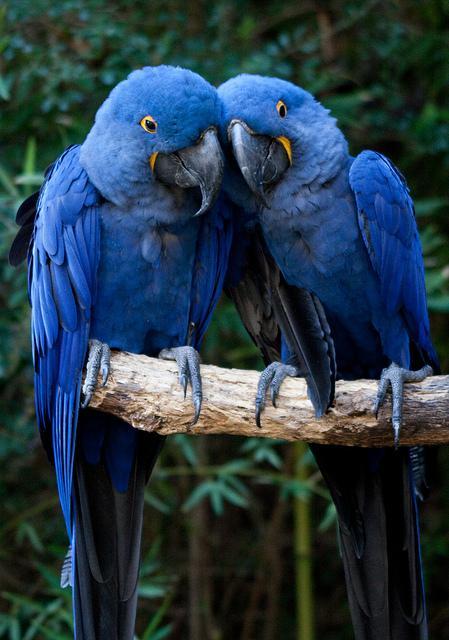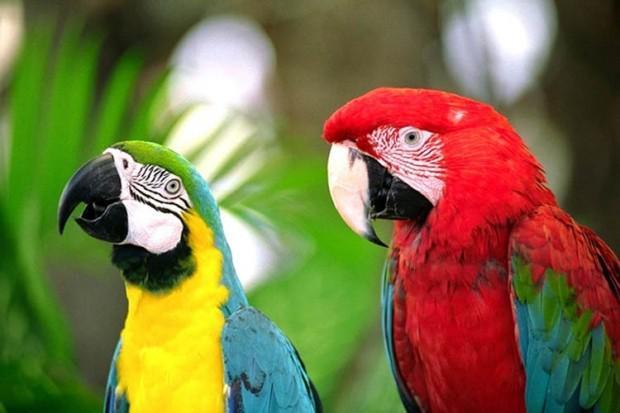The first image is the image on the left, the second image is the image on the right. Given the left and right images, does the statement "A blue bird is touching another blue bird." hold true? Answer yes or no. Yes. The first image is the image on the left, the second image is the image on the right. Given the left and right images, does the statement "One of the images has two matching solid colored birds standing next to each other on the same branch." hold true? Answer yes or no. Yes. 